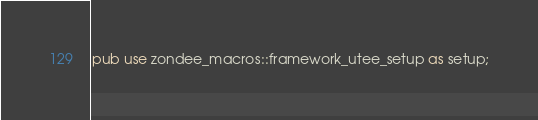<code> <loc_0><loc_0><loc_500><loc_500><_Rust_>pub use zondee_macros::framework_utee_setup as setup;
</code> 